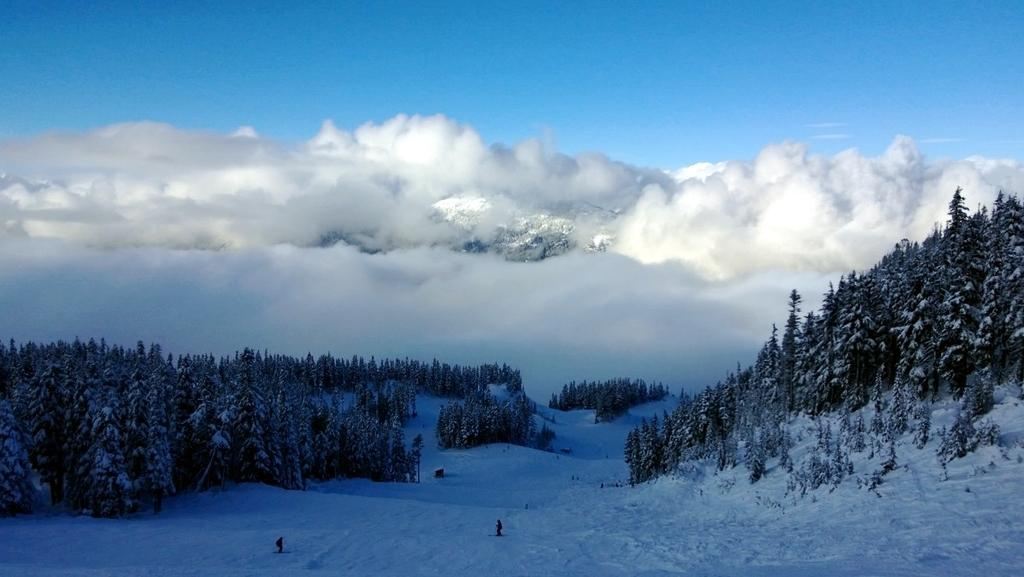What is the main feature of the image? The image contains a beautiful view of snow. What can be seen in the foreground of the image? There are many trees in the front of the image. How does the snow appear on the ground? Snow is present on the ground in the image. What can be seen in the background of the image? There are huge clouds visible in the background. What is visible at the top of the image? The sky is visible at the top of the image. What type of society can be seen interacting with the mailbox in the image? There is no mailbox present in the image; it features a beautiful view of snow with trees, clouds, and snow on the ground. 